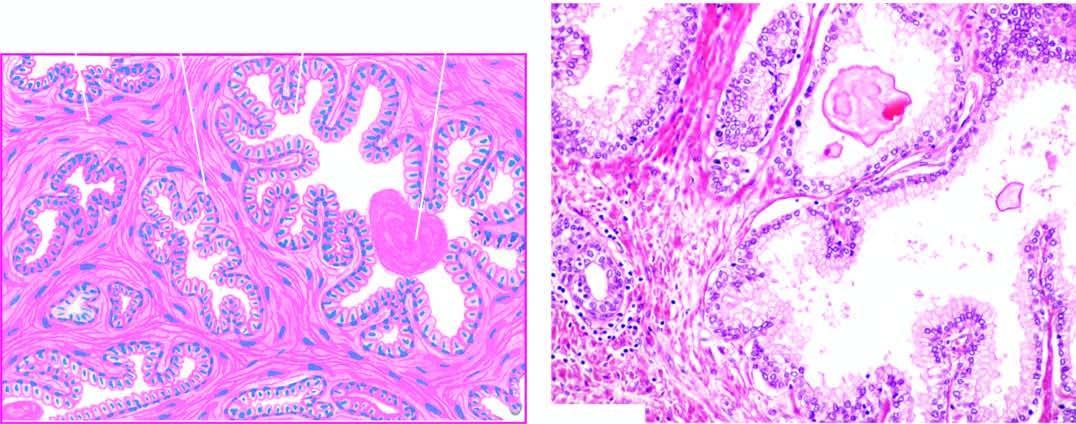re there areas of intra-acinar papillary infoldings lined by two layers of epithelium with basal polarity of nuclei?
Answer the question using a single word or phrase. Yes 